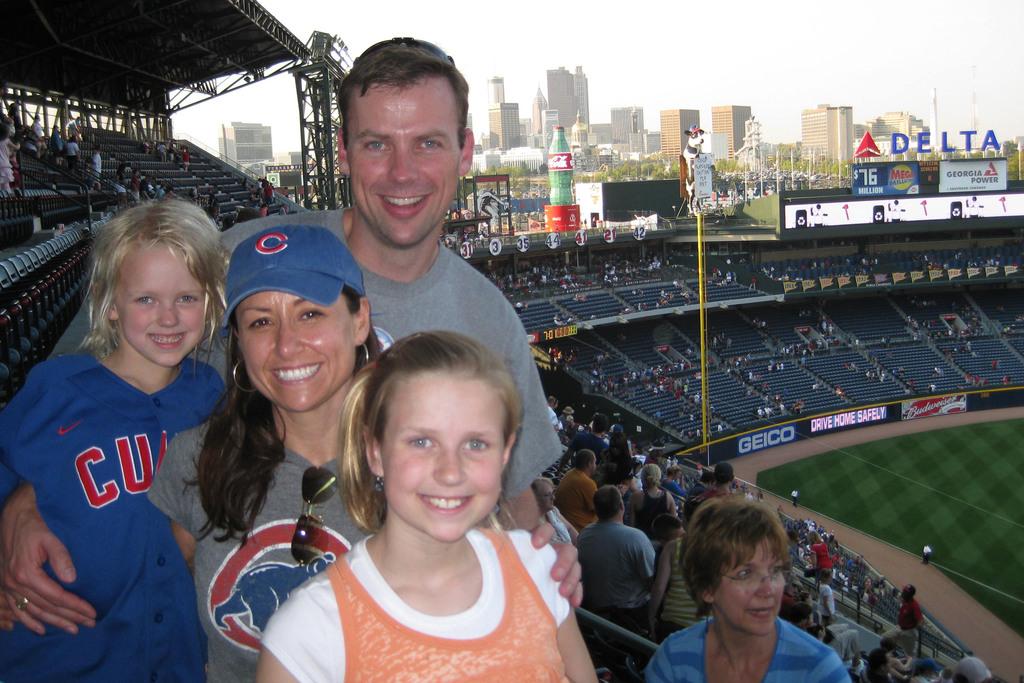What team is on her hat?
Your response must be concise. Cubs. 